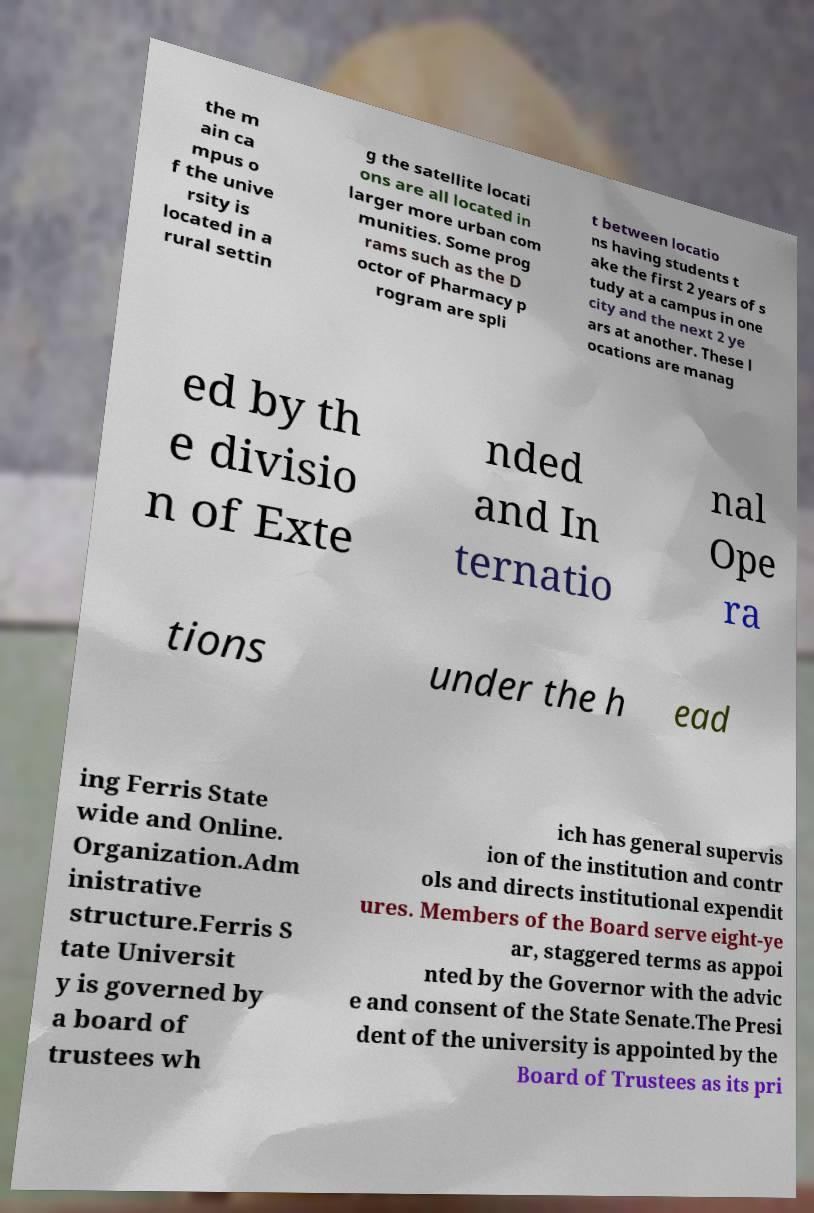Please identify and transcribe the text found in this image. the m ain ca mpus o f the unive rsity is located in a rural settin g the satellite locati ons are all located in larger more urban com munities. Some prog rams such as the D octor of Pharmacy p rogram are spli t between locatio ns having students t ake the first 2 years of s tudy at a campus in one city and the next 2 ye ars at another. These l ocations are manag ed by th e divisio n of Exte nded and In ternatio nal Ope ra tions under the h ead ing Ferris State wide and Online. Organization.Adm inistrative structure.Ferris S tate Universit y is governed by a board of trustees wh ich has general supervis ion of the institution and contr ols and directs institutional expendit ures. Members of the Board serve eight-ye ar, staggered terms as appoi nted by the Governor with the advic e and consent of the State Senate.The Presi dent of the university is appointed by the Board of Trustees as its pri 